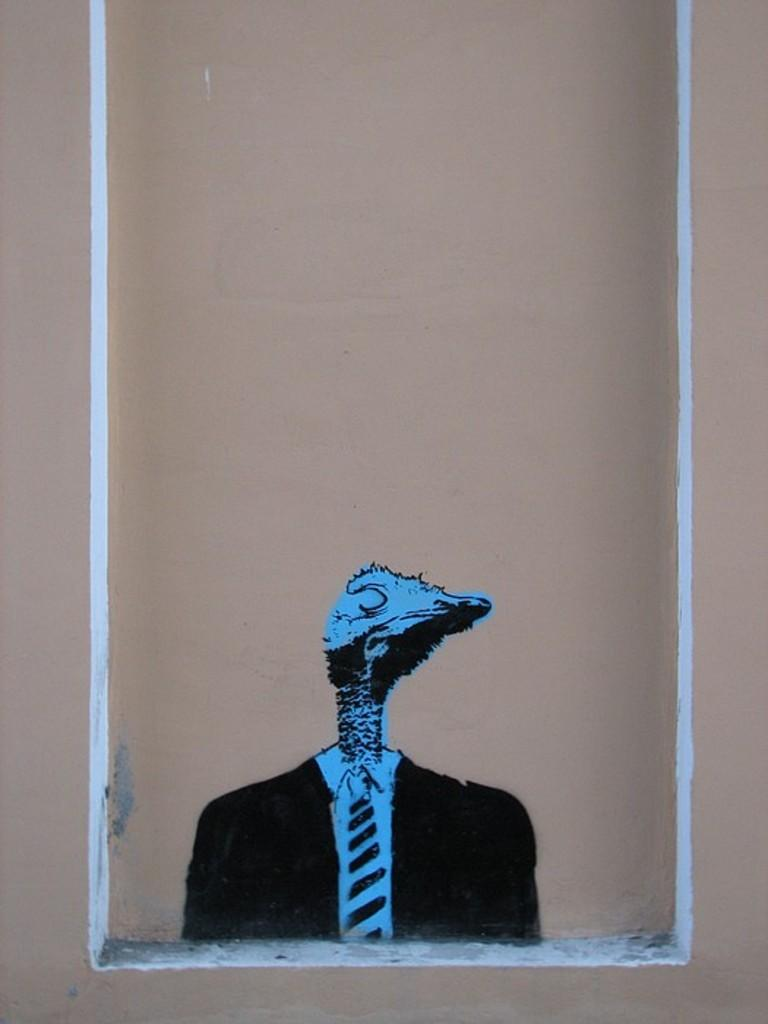What type of artwork is depicted in the image? The image is a painting. Where is the painting located? The painting is on a wall. What type of apparatus is used by the crowd in the painting? There is no crowd present in the painting, and therefore no apparatus can be observed. 